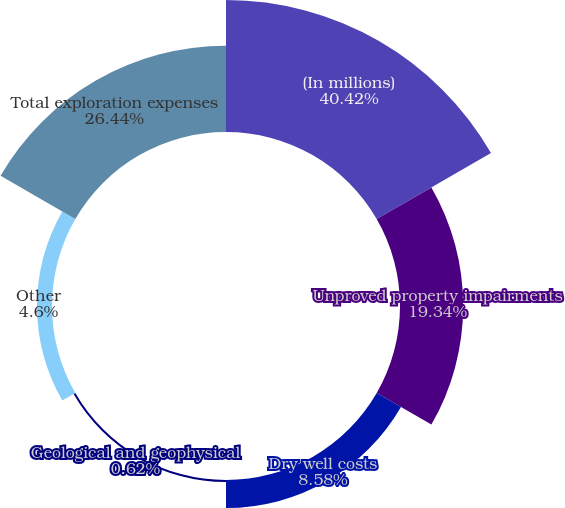Convert chart to OTSL. <chart><loc_0><loc_0><loc_500><loc_500><pie_chart><fcel>(In millions)<fcel>Unproved property impairments<fcel>Dry well costs<fcel>Geological and geophysical<fcel>Other<fcel>Total exploration expenses<nl><fcel>40.42%<fcel>19.34%<fcel>8.58%<fcel>0.62%<fcel>4.6%<fcel>26.44%<nl></chart> 